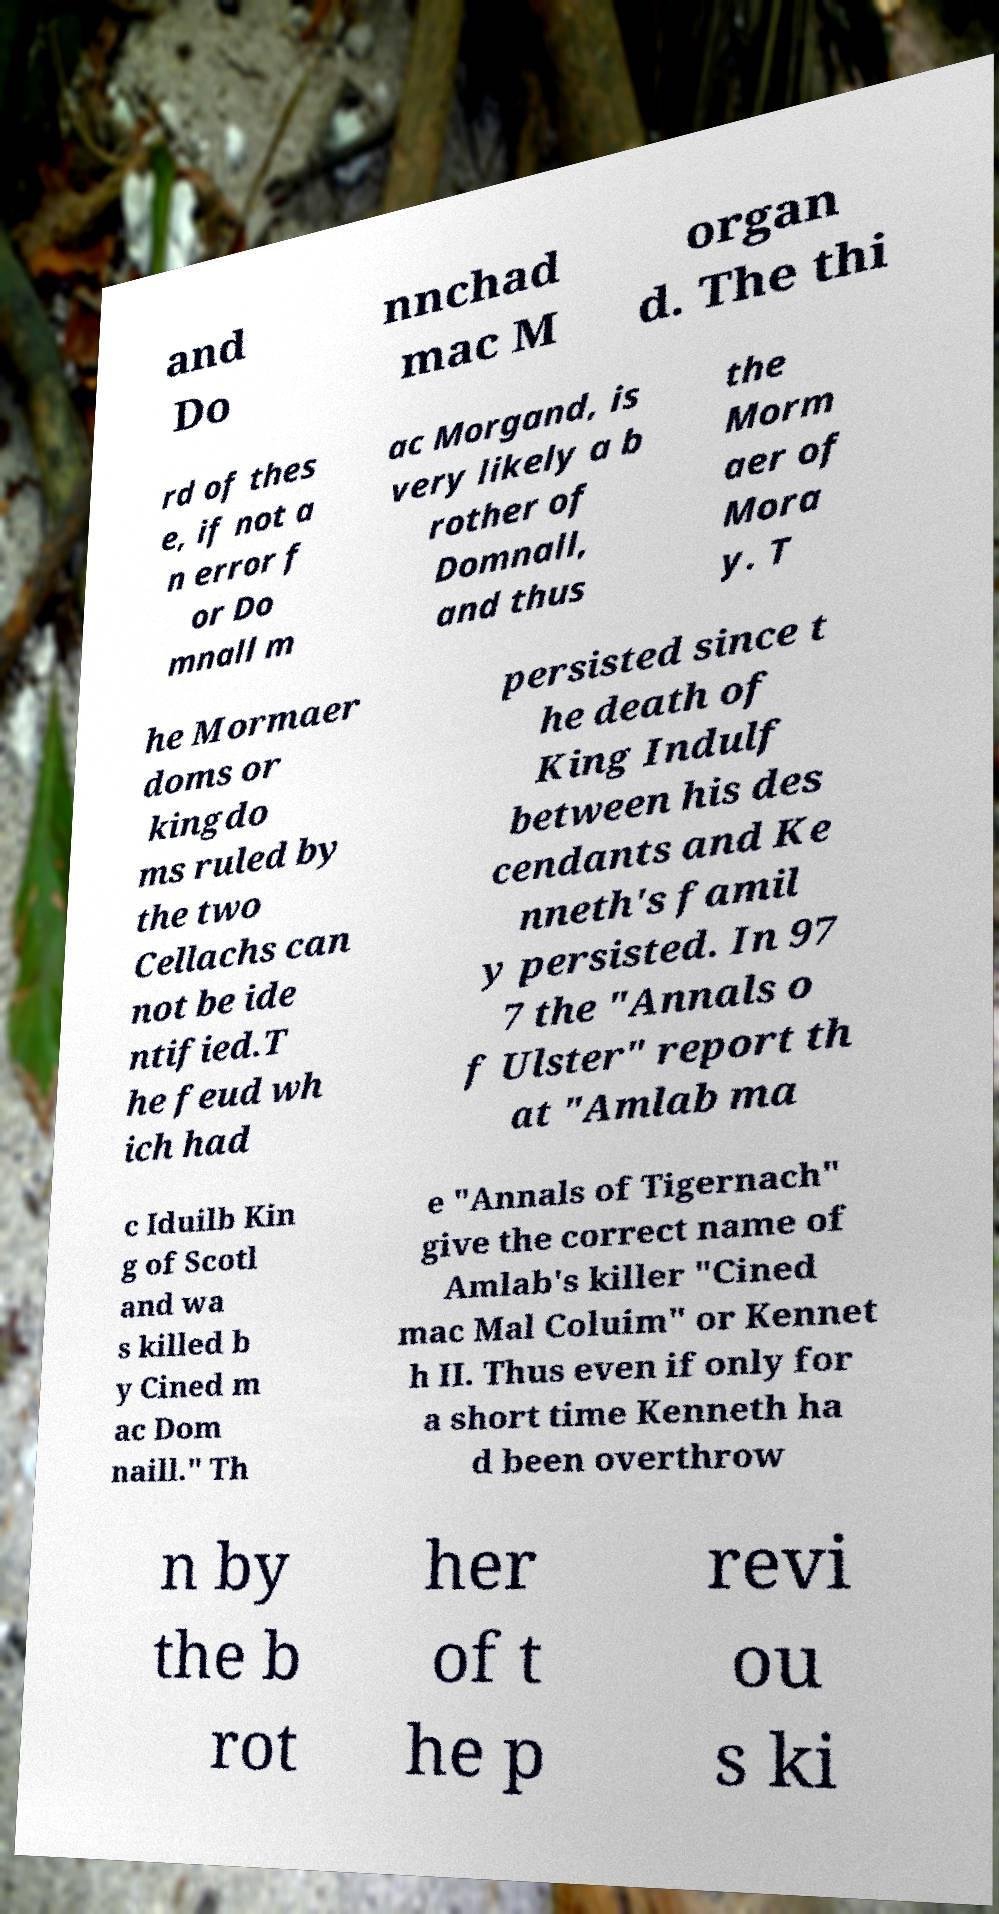For documentation purposes, I need the text within this image transcribed. Could you provide that? and Do nnchad mac M organ d. The thi rd of thes e, if not a n error f or Do mnall m ac Morgand, is very likely a b rother of Domnall, and thus the Morm aer of Mora y. T he Mormaer doms or kingdo ms ruled by the two Cellachs can not be ide ntified.T he feud wh ich had persisted since t he death of King Indulf between his des cendants and Ke nneth's famil y persisted. In 97 7 the "Annals o f Ulster" report th at "Amlab ma c Iduilb Kin g of Scotl and wa s killed b y Cined m ac Dom naill." Th e "Annals of Tigernach" give the correct name of Amlab's killer "Cined mac Mal Coluim" or Kennet h II. Thus even if only for a short time Kenneth ha d been overthrow n by the b rot her of t he p revi ou s ki 